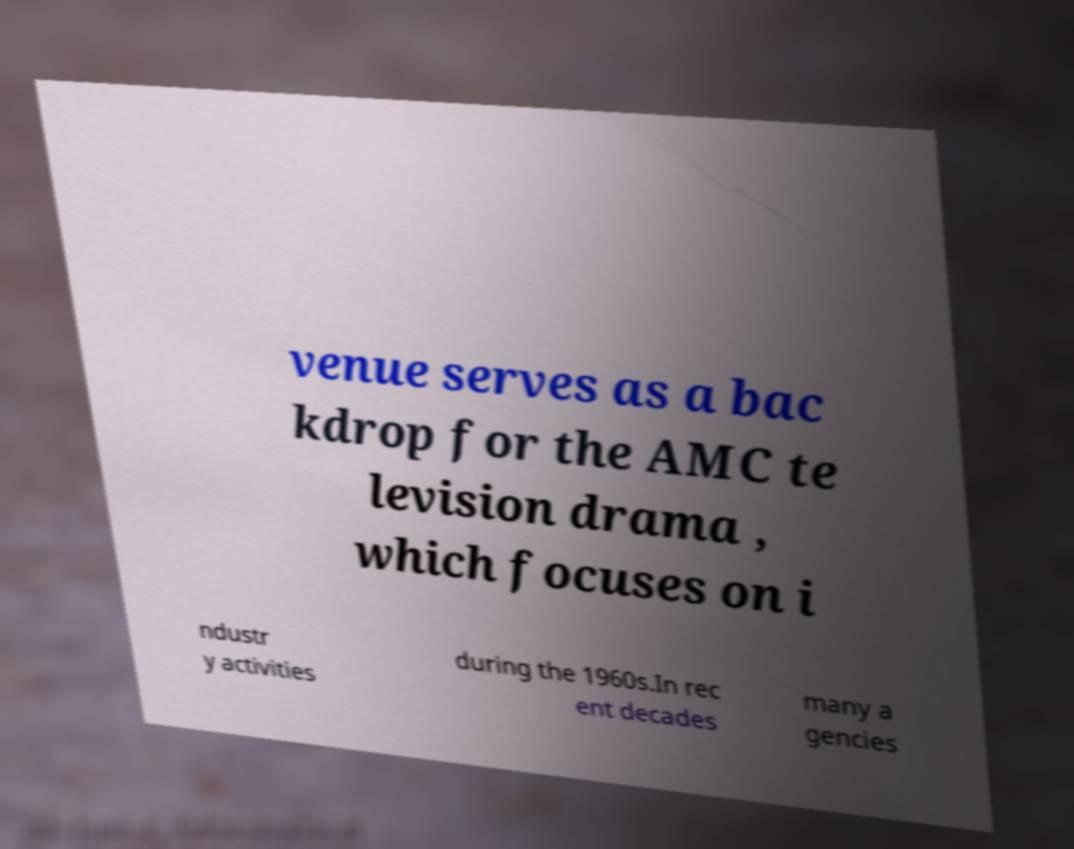Can you read and provide the text displayed in the image?This photo seems to have some interesting text. Can you extract and type it out for me? venue serves as a bac kdrop for the AMC te levision drama , which focuses on i ndustr y activities during the 1960s.In rec ent decades many a gencies 